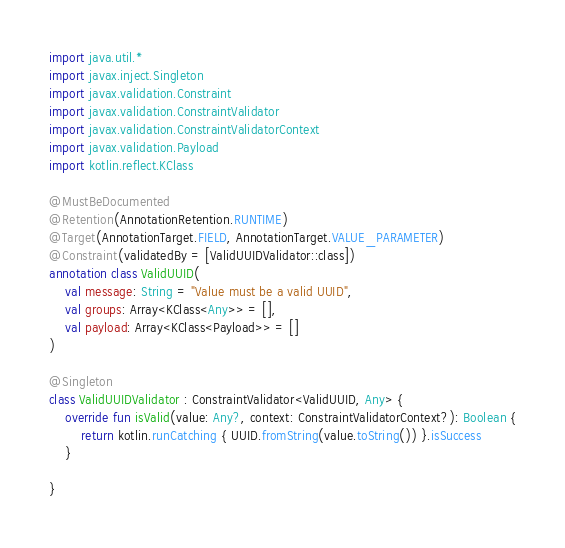Convert code to text. <code><loc_0><loc_0><loc_500><loc_500><_Kotlin_>import java.util.*
import javax.inject.Singleton
import javax.validation.Constraint
import javax.validation.ConstraintValidator
import javax.validation.ConstraintValidatorContext
import javax.validation.Payload
import kotlin.reflect.KClass

@MustBeDocumented
@Retention(AnnotationRetention.RUNTIME)
@Target(AnnotationTarget.FIELD, AnnotationTarget.VALUE_PARAMETER)
@Constraint(validatedBy = [ValidUUIDValidator::class])
annotation class ValidUUID(
    val message: String = "Value must be a valid UUID",
    val groups: Array<KClass<Any>> = [],
    val payload: Array<KClass<Payload>> = []
)

@Singleton
class ValidUUIDValidator : ConstraintValidator<ValidUUID, Any> {
    override fun isValid(value: Any?, context: ConstraintValidatorContext?): Boolean {
        return kotlin.runCatching { UUID.fromString(value.toString()) }.isSuccess
    }

}
</code> 